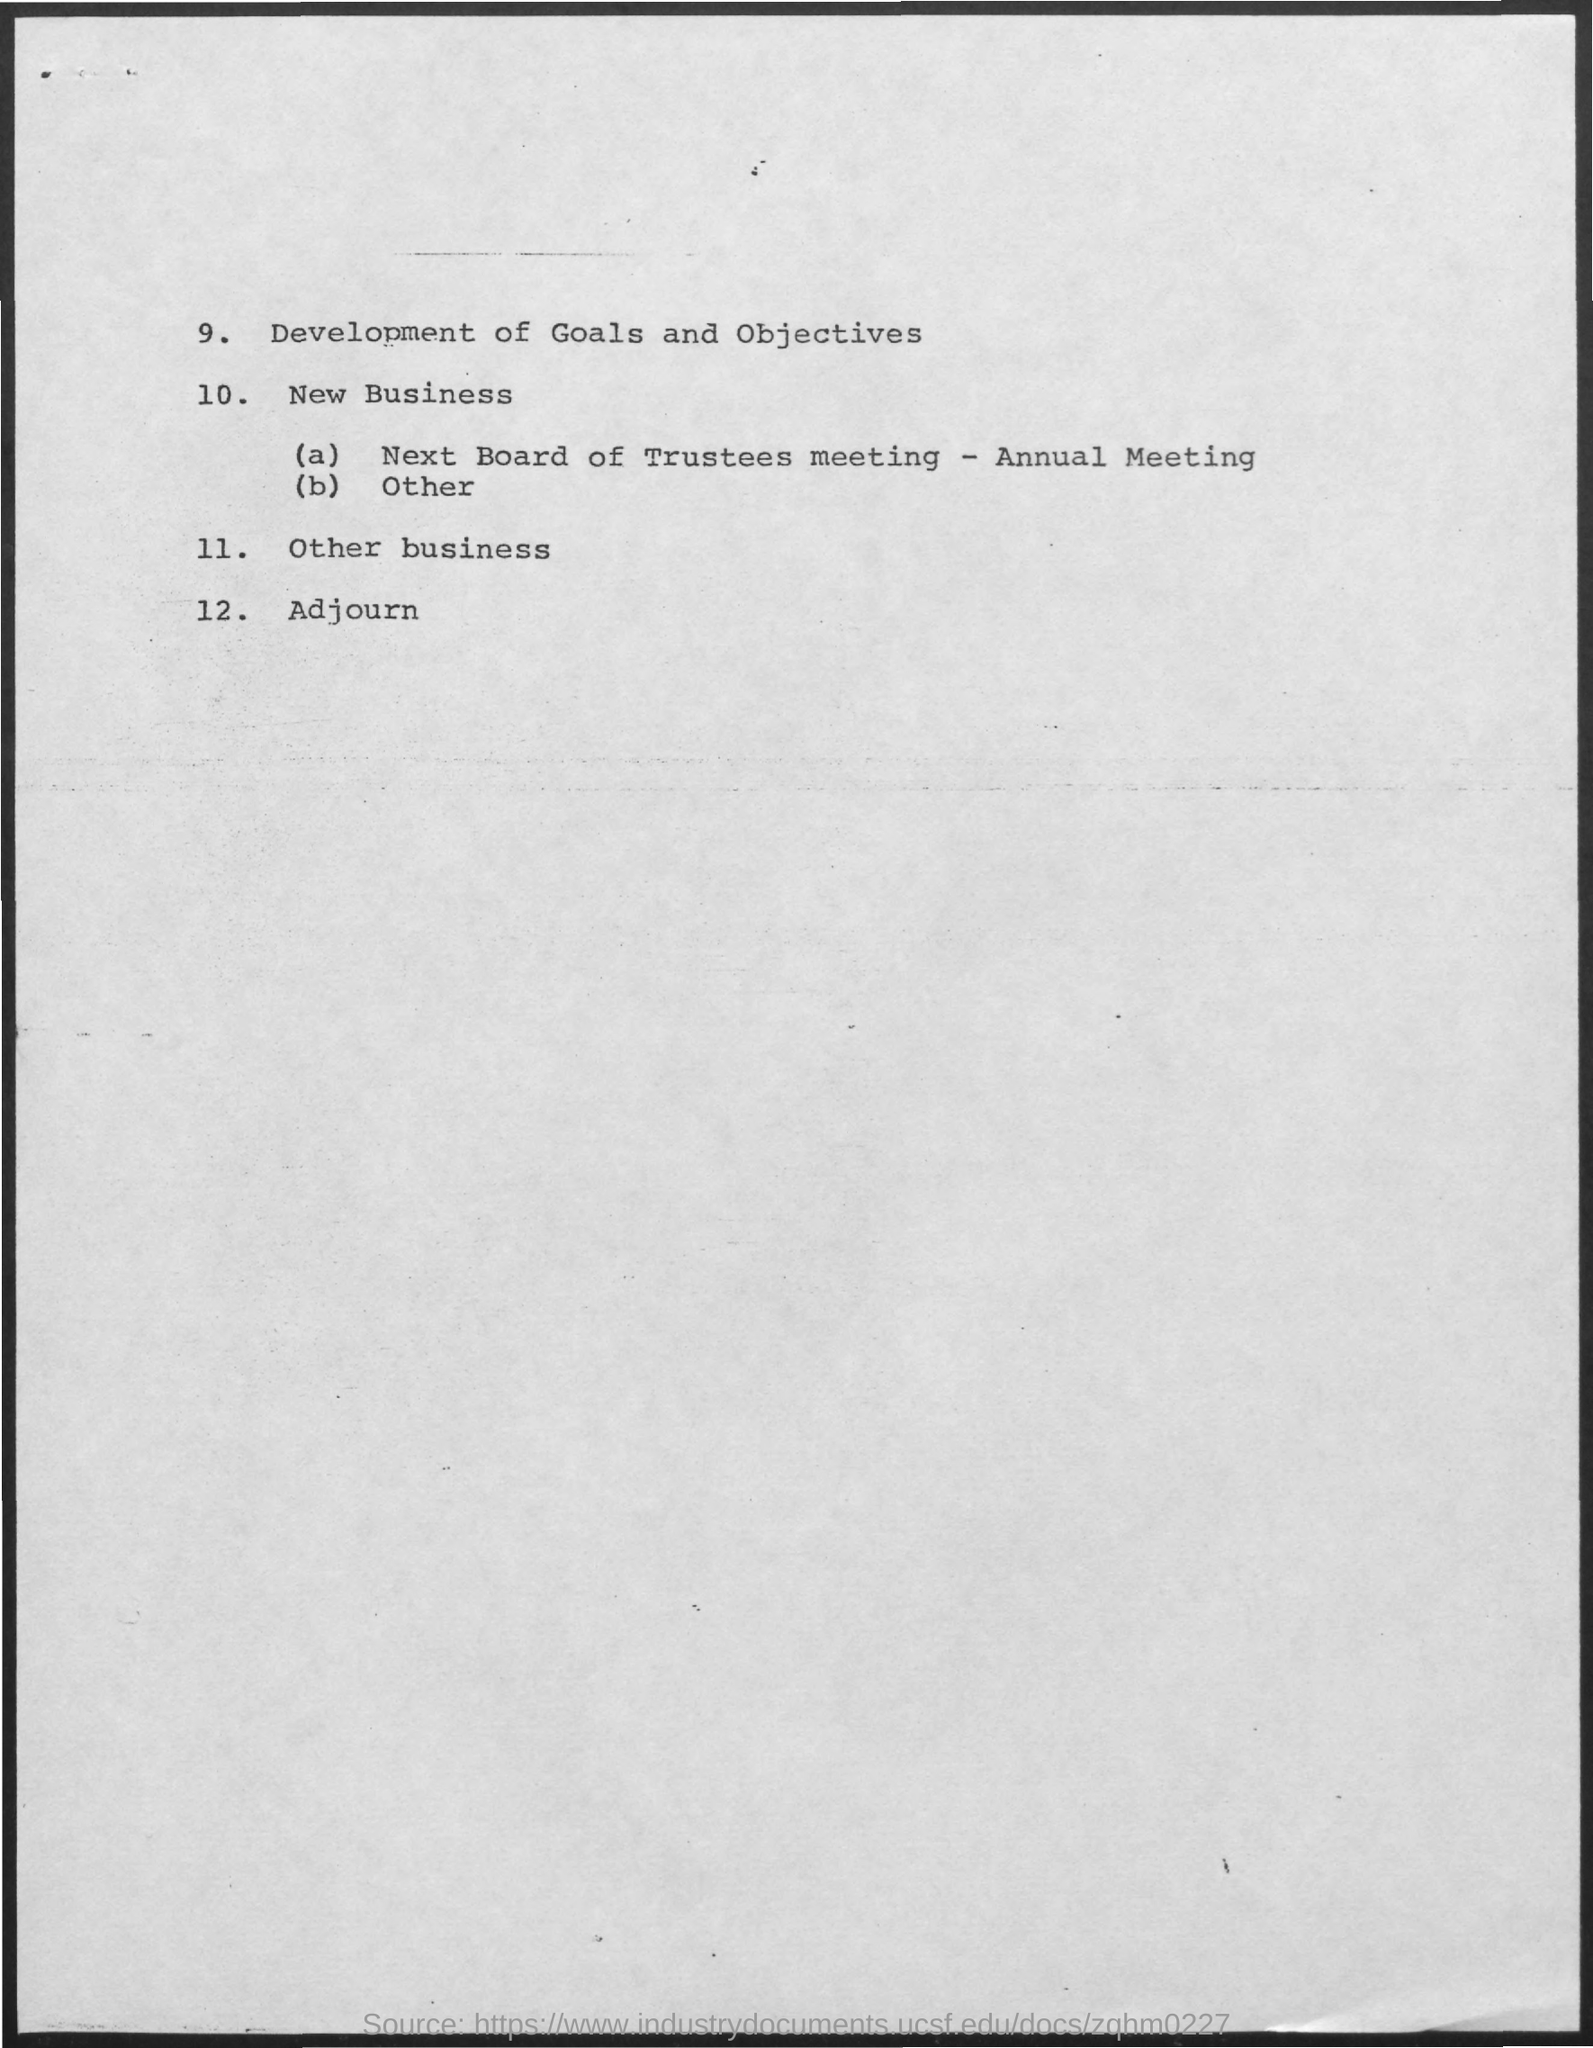What is the 12th point?
Make the answer very short. Adjourn. 